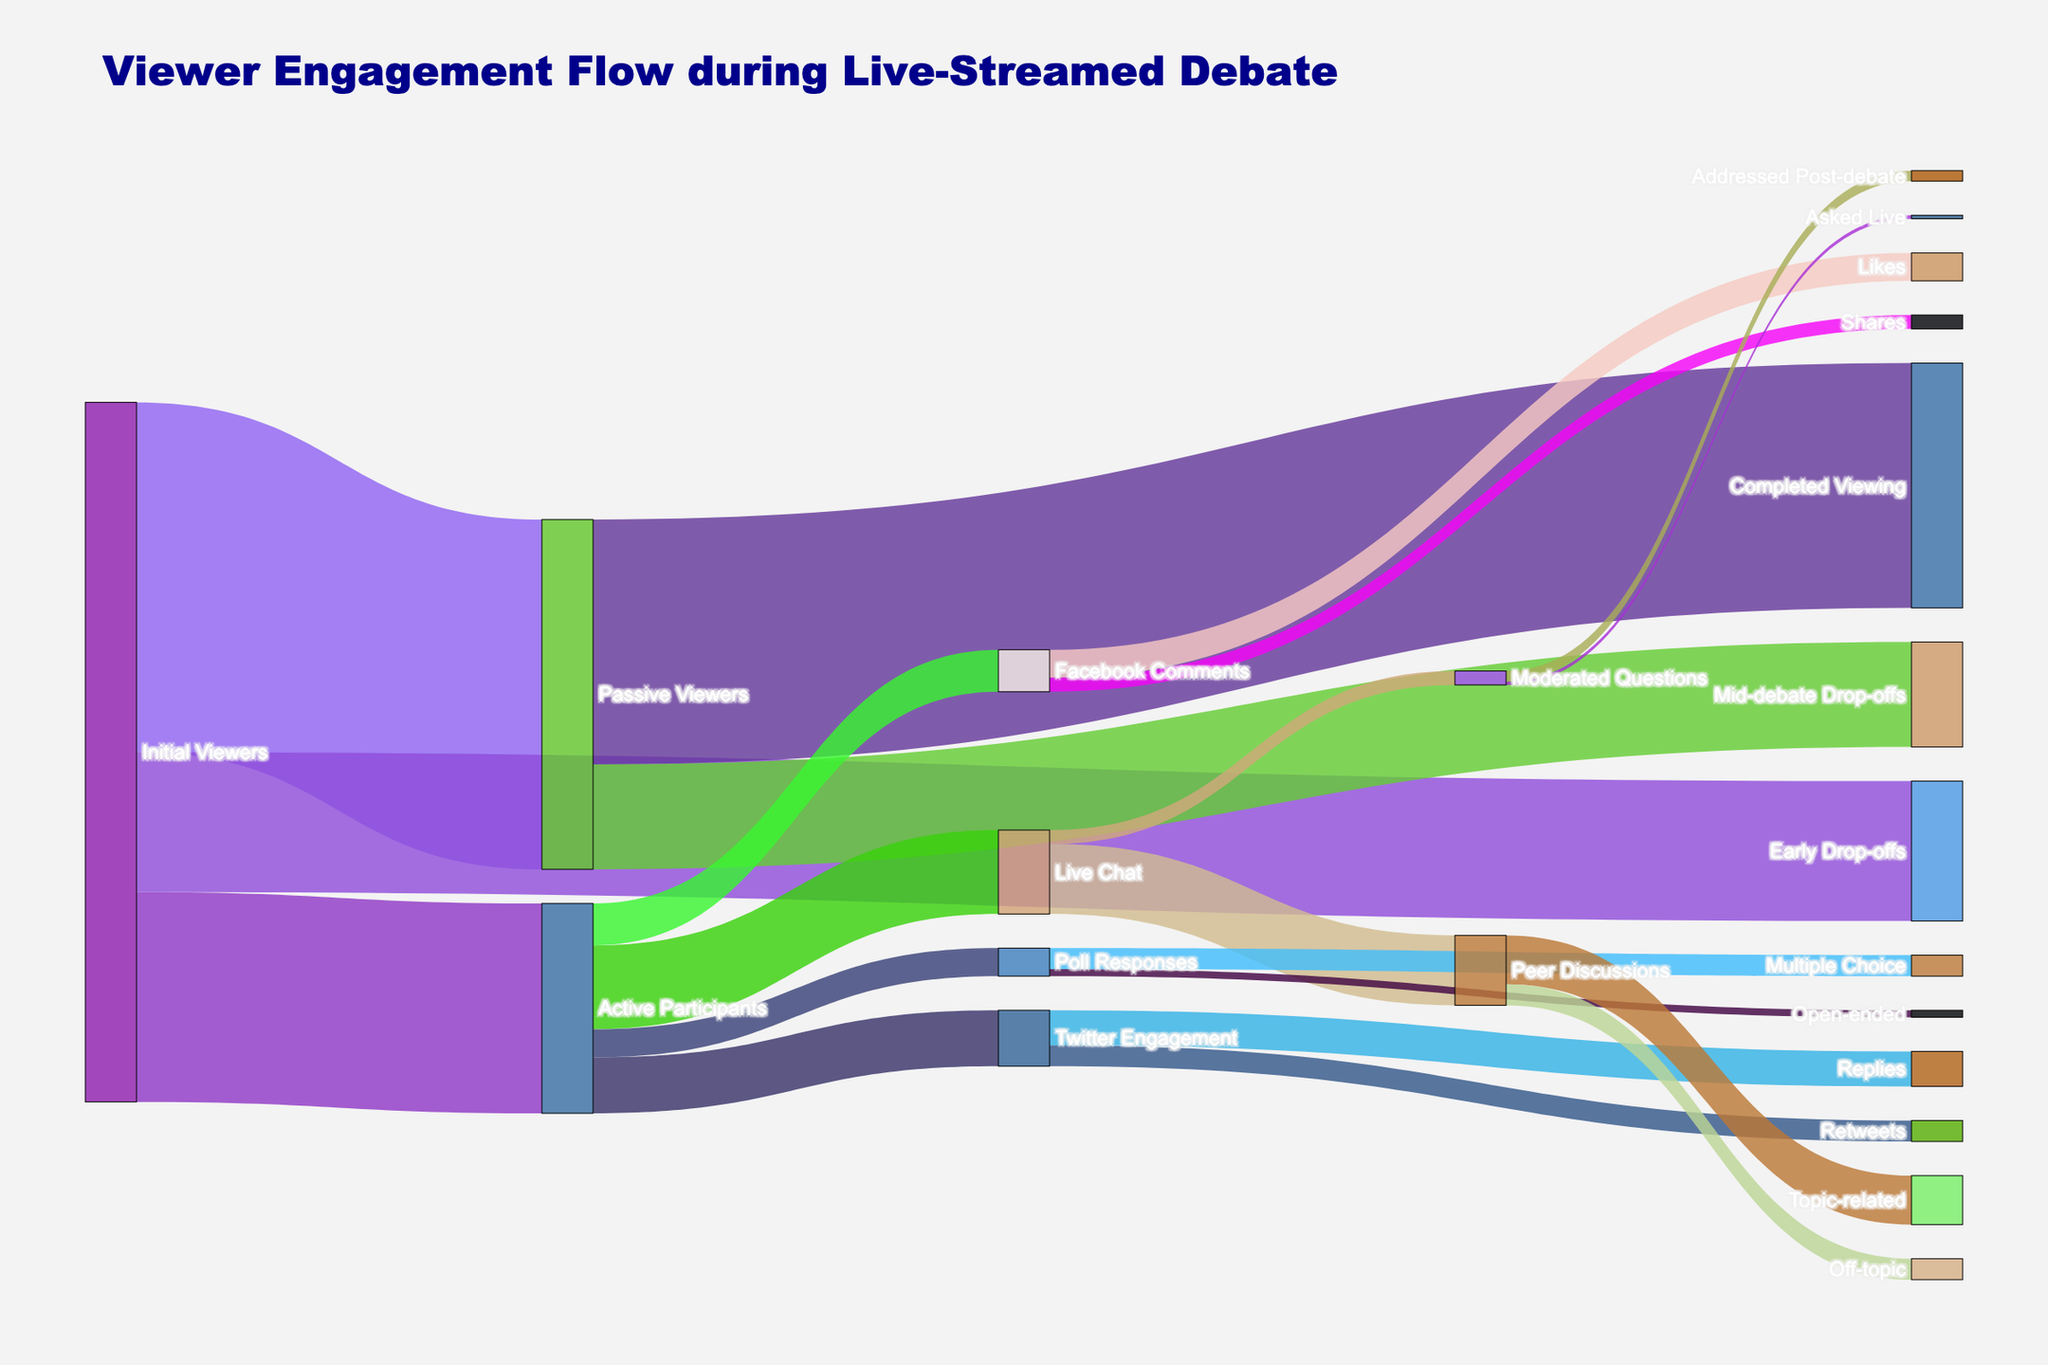What is the title of the Sankey Diagram? The title is usually displayed at the top of the diagram in a larger and bold font. In this case, the title clearly describes the main focus of the diagram.
Answer: Viewer Engagement Flow during Live-Streamed Debate How many initial viewers became passive viewers? To answer this question, look for the link and value labeled 'Initial Viewers' flowing to 'Passive Viewers' in the figure.
Answer: 50,000 Which category has the highest number of final engagements from active participants, and what is that number? Examine the flows from 'Active Participants' to their subsequent categories ('Live Chat', 'Twitter Engagement', 'Facebook Comments', 'Poll Responses'). Identify which has the highest value.
Answer: Live Chat, 12,000 How many viewers dropped off early? Identify the flow from 'Initial Viewers' to 'Early Drop-offs' and note the corresponding value.
Answer: 20,000 What are the two sub-categories under 'Live Chat', and what are their values? Look at the branches extending from 'Live Chat' and check their labels and values.
Answer: Moderated Questions, Peer Discussions (2000, 10,000) Which transition has the lowest value, and what is that value? Scan the entire diagram, comparing the values of all transitions and identify the smallest one.
Answer: Moderated Questions to Asked Live, 500 